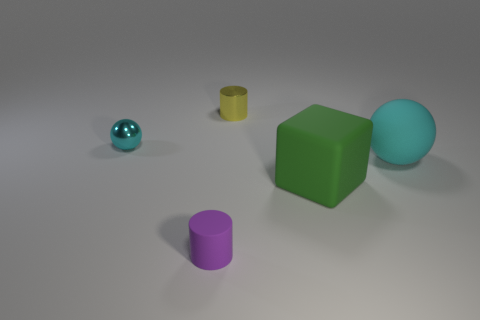Are there any spheres that are behind the cyan ball on the right side of the yellow cylinder?
Offer a very short reply. Yes. There is a small object that is both behind the tiny purple rubber thing and in front of the yellow thing; what material is it?
Your response must be concise. Metal. There is a small cylinder that is on the left side of the tiny metal thing that is right of the cyan sphere that is to the left of the yellow shiny cylinder; what is its color?
Offer a terse response. Purple. There is a metal cylinder that is the same size as the shiny sphere; what color is it?
Your answer should be compact. Yellow. Does the tiny ball have the same color as the ball to the right of the matte cylinder?
Your answer should be compact. Yes. What is the material of the small cylinder that is behind the tiny thing in front of the cyan metal object?
Ensure brevity in your answer.  Metal. How many cylinders are behind the big cube and in front of the yellow cylinder?
Give a very brief answer. 0. How many other objects are there of the same size as the metal sphere?
Give a very brief answer. 2. There is a small shiny thing behind the small metal sphere; does it have the same shape as the matte object in front of the big block?
Provide a short and direct response. Yes. Are there any blocks behind the tiny cyan thing?
Ensure brevity in your answer.  No. 